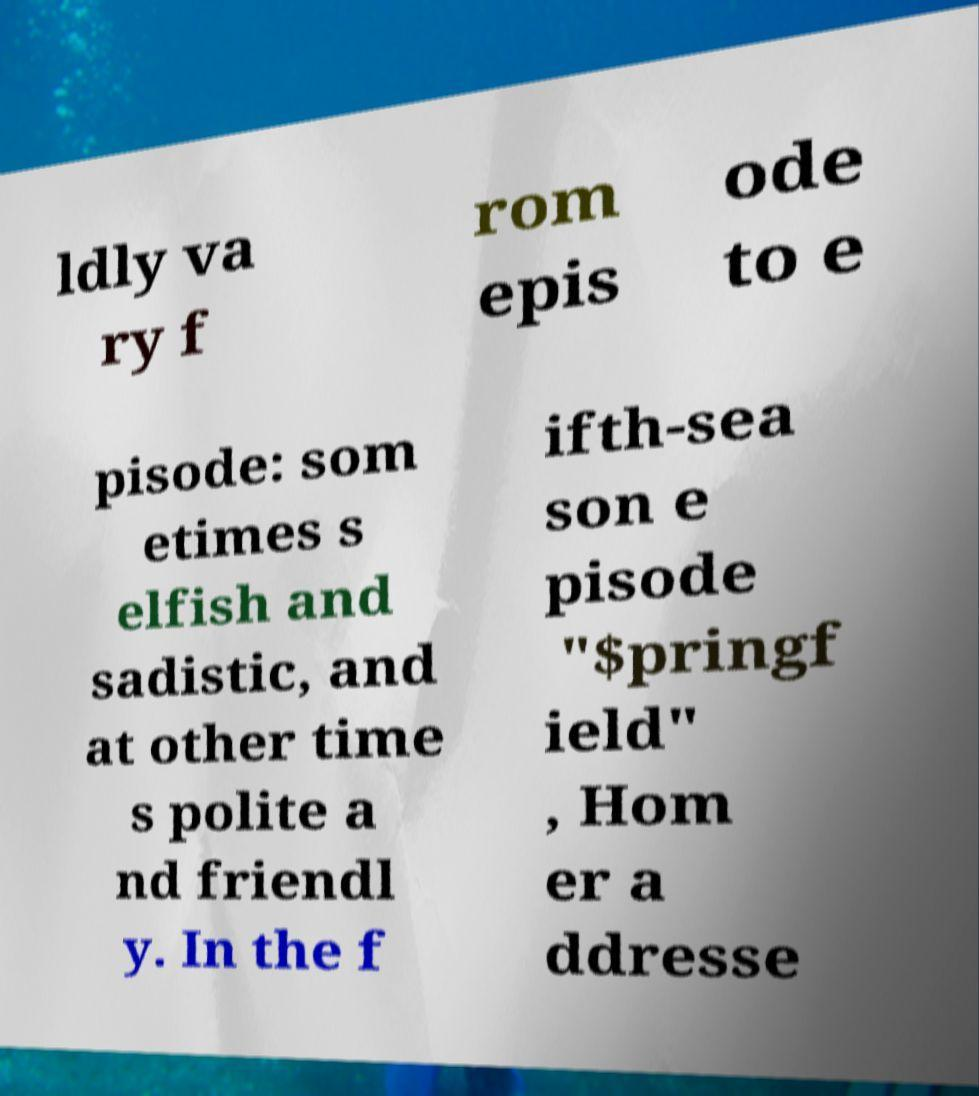Can you accurately transcribe the text from the provided image for me? ldly va ry f rom epis ode to e pisode: som etimes s elfish and sadistic, and at other time s polite a nd friendl y. In the f ifth-sea son e pisode "$pringf ield" , Hom er a ddresse 